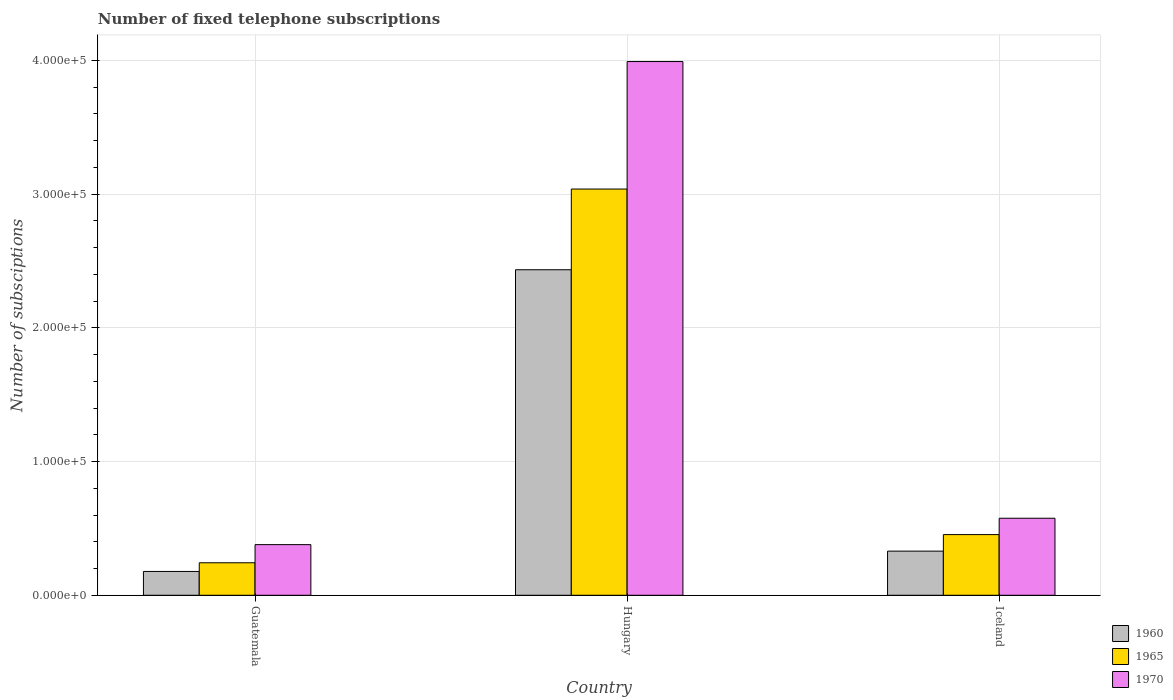How many different coloured bars are there?
Provide a short and direct response. 3. How many groups of bars are there?
Make the answer very short. 3. How many bars are there on the 1st tick from the right?
Give a very brief answer. 3. What is the label of the 2nd group of bars from the left?
Provide a short and direct response. Hungary. What is the number of fixed telephone subscriptions in 1960 in Iceland?
Give a very brief answer. 3.30e+04. Across all countries, what is the maximum number of fixed telephone subscriptions in 1970?
Ensure brevity in your answer.  3.99e+05. Across all countries, what is the minimum number of fixed telephone subscriptions in 1970?
Provide a succinct answer. 3.79e+04. In which country was the number of fixed telephone subscriptions in 1970 maximum?
Give a very brief answer. Hungary. In which country was the number of fixed telephone subscriptions in 1970 minimum?
Make the answer very short. Guatemala. What is the total number of fixed telephone subscriptions in 1960 in the graph?
Make the answer very short. 2.94e+05. What is the difference between the number of fixed telephone subscriptions in 1960 in Hungary and that in Iceland?
Give a very brief answer. 2.10e+05. What is the difference between the number of fixed telephone subscriptions in 1965 in Guatemala and the number of fixed telephone subscriptions in 1960 in Hungary?
Keep it short and to the point. -2.19e+05. What is the average number of fixed telephone subscriptions in 1970 per country?
Your answer should be compact. 1.65e+05. What is the difference between the number of fixed telephone subscriptions of/in 1965 and number of fixed telephone subscriptions of/in 1960 in Hungary?
Ensure brevity in your answer.  6.04e+04. What is the ratio of the number of fixed telephone subscriptions in 1960 in Guatemala to that in Iceland?
Make the answer very short. 0.54. Is the number of fixed telephone subscriptions in 1960 in Guatemala less than that in Hungary?
Your response must be concise. Yes. What is the difference between the highest and the second highest number of fixed telephone subscriptions in 1970?
Offer a very short reply. 3.41e+05. What is the difference between the highest and the lowest number of fixed telephone subscriptions in 1965?
Make the answer very short. 2.79e+05. What does the 1st bar from the left in Hungary represents?
Offer a very short reply. 1960. What does the 2nd bar from the right in Iceland represents?
Offer a very short reply. 1965. How many bars are there?
Keep it short and to the point. 9. Are all the bars in the graph horizontal?
Your response must be concise. No. What is the difference between two consecutive major ticks on the Y-axis?
Offer a terse response. 1.00e+05. Are the values on the major ticks of Y-axis written in scientific E-notation?
Make the answer very short. Yes. Where does the legend appear in the graph?
Keep it short and to the point. Bottom right. How are the legend labels stacked?
Offer a terse response. Vertical. What is the title of the graph?
Offer a terse response. Number of fixed telephone subscriptions. Does "2006" appear as one of the legend labels in the graph?
Make the answer very short. No. What is the label or title of the X-axis?
Provide a succinct answer. Country. What is the label or title of the Y-axis?
Offer a terse response. Number of subsciptions. What is the Number of subsciptions in 1960 in Guatemala?
Offer a terse response. 1.78e+04. What is the Number of subsciptions in 1965 in Guatemala?
Your answer should be very brief. 2.43e+04. What is the Number of subsciptions in 1970 in Guatemala?
Keep it short and to the point. 3.79e+04. What is the Number of subsciptions in 1960 in Hungary?
Your answer should be compact. 2.43e+05. What is the Number of subsciptions of 1965 in Hungary?
Your response must be concise. 3.04e+05. What is the Number of subsciptions of 1970 in Hungary?
Your answer should be very brief. 3.99e+05. What is the Number of subsciptions in 1960 in Iceland?
Give a very brief answer. 3.30e+04. What is the Number of subsciptions in 1965 in Iceland?
Ensure brevity in your answer.  4.54e+04. What is the Number of subsciptions of 1970 in Iceland?
Provide a short and direct response. 5.76e+04. Across all countries, what is the maximum Number of subsciptions in 1960?
Offer a very short reply. 2.43e+05. Across all countries, what is the maximum Number of subsciptions in 1965?
Offer a terse response. 3.04e+05. Across all countries, what is the maximum Number of subsciptions in 1970?
Offer a very short reply. 3.99e+05. Across all countries, what is the minimum Number of subsciptions in 1960?
Offer a terse response. 1.78e+04. Across all countries, what is the minimum Number of subsciptions of 1965?
Give a very brief answer. 2.43e+04. Across all countries, what is the minimum Number of subsciptions in 1970?
Offer a very short reply. 3.79e+04. What is the total Number of subsciptions in 1960 in the graph?
Give a very brief answer. 2.94e+05. What is the total Number of subsciptions in 1965 in the graph?
Your answer should be compact. 3.73e+05. What is the total Number of subsciptions of 1970 in the graph?
Your response must be concise. 4.95e+05. What is the difference between the Number of subsciptions in 1960 in Guatemala and that in Hungary?
Your response must be concise. -2.26e+05. What is the difference between the Number of subsciptions in 1965 in Guatemala and that in Hungary?
Give a very brief answer. -2.79e+05. What is the difference between the Number of subsciptions in 1970 in Guatemala and that in Hungary?
Offer a very short reply. -3.61e+05. What is the difference between the Number of subsciptions in 1960 in Guatemala and that in Iceland?
Your answer should be very brief. -1.52e+04. What is the difference between the Number of subsciptions of 1965 in Guatemala and that in Iceland?
Offer a very short reply. -2.11e+04. What is the difference between the Number of subsciptions of 1970 in Guatemala and that in Iceland?
Offer a very short reply. -1.97e+04. What is the difference between the Number of subsciptions in 1960 in Hungary and that in Iceland?
Provide a succinct answer. 2.10e+05. What is the difference between the Number of subsciptions in 1965 in Hungary and that in Iceland?
Your answer should be compact. 2.58e+05. What is the difference between the Number of subsciptions in 1970 in Hungary and that in Iceland?
Make the answer very short. 3.41e+05. What is the difference between the Number of subsciptions in 1960 in Guatemala and the Number of subsciptions in 1965 in Hungary?
Give a very brief answer. -2.86e+05. What is the difference between the Number of subsciptions in 1960 in Guatemala and the Number of subsciptions in 1970 in Hungary?
Ensure brevity in your answer.  -3.81e+05. What is the difference between the Number of subsciptions in 1965 in Guatemala and the Number of subsciptions in 1970 in Hungary?
Your answer should be compact. -3.75e+05. What is the difference between the Number of subsciptions of 1960 in Guatemala and the Number of subsciptions of 1965 in Iceland?
Your answer should be very brief. -2.75e+04. What is the difference between the Number of subsciptions of 1960 in Guatemala and the Number of subsciptions of 1970 in Iceland?
Your answer should be very brief. -3.98e+04. What is the difference between the Number of subsciptions in 1965 in Guatemala and the Number of subsciptions in 1970 in Iceland?
Offer a very short reply. -3.33e+04. What is the difference between the Number of subsciptions of 1960 in Hungary and the Number of subsciptions of 1965 in Iceland?
Keep it short and to the point. 1.98e+05. What is the difference between the Number of subsciptions in 1960 in Hungary and the Number of subsciptions in 1970 in Iceland?
Provide a short and direct response. 1.86e+05. What is the difference between the Number of subsciptions in 1965 in Hungary and the Number of subsciptions in 1970 in Iceland?
Your answer should be very brief. 2.46e+05. What is the average Number of subsciptions of 1960 per country?
Your response must be concise. 9.81e+04. What is the average Number of subsciptions in 1965 per country?
Ensure brevity in your answer.  1.24e+05. What is the average Number of subsciptions in 1970 per country?
Ensure brevity in your answer.  1.65e+05. What is the difference between the Number of subsciptions of 1960 and Number of subsciptions of 1965 in Guatemala?
Keep it short and to the point. -6485. What is the difference between the Number of subsciptions of 1960 and Number of subsciptions of 1970 in Guatemala?
Make the answer very short. -2.00e+04. What is the difference between the Number of subsciptions of 1965 and Number of subsciptions of 1970 in Guatemala?
Offer a very short reply. -1.36e+04. What is the difference between the Number of subsciptions of 1960 and Number of subsciptions of 1965 in Hungary?
Offer a terse response. -6.04e+04. What is the difference between the Number of subsciptions of 1960 and Number of subsciptions of 1970 in Hungary?
Offer a terse response. -1.56e+05. What is the difference between the Number of subsciptions of 1965 and Number of subsciptions of 1970 in Hungary?
Make the answer very short. -9.53e+04. What is the difference between the Number of subsciptions of 1960 and Number of subsciptions of 1965 in Iceland?
Offer a terse response. -1.24e+04. What is the difference between the Number of subsciptions in 1960 and Number of subsciptions in 1970 in Iceland?
Your answer should be compact. -2.46e+04. What is the difference between the Number of subsciptions of 1965 and Number of subsciptions of 1970 in Iceland?
Offer a very short reply. -1.22e+04. What is the ratio of the Number of subsciptions of 1960 in Guatemala to that in Hungary?
Provide a succinct answer. 0.07. What is the ratio of the Number of subsciptions of 1970 in Guatemala to that in Hungary?
Your answer should be compact. 0.09. What is the ratio of the Number of subsciptions in 1960 in Guatemala to that in Iceland?
Provide a short and direct response. 0.54. What is the ratio of the Number of subsciptions in 1965 in Guatemala to that in Iceland?
Keep it short and to the point. 0.54. What is the ratio of the Number of subsciptions of 1970 in Guatemala to that in Iceland?
Make the answer very short. 0.66. What is the ratio of the Number of subsciptions in 1960 in Hungary to that in Iceland?
Ensure brevity in your answer.  7.38. What is the ratio of the Number of subsciptions of 1965 in Hungary to that in Iceland?
Your response must be concise. 6.7. What is the ratio of the Number of subsciptions of 1970 in Hungary to that in Iceland?
Your response must be concise. 6.93. What is the difference between the highest and the second highest Number of subsciptions of 1960?
Ensure brevity in your answer.  2.10e+05. What is the difference between the highest and the second highest Number of subsciptions in 1965?
Offer a terse response. 2.58e+05. What is the difference between the highest and the second highest Number of subsciptions in 1970?
Ensure brevity in your answer.  3.41e+05. What is the difference between the highest and the lowest Number of subsciptions in 1960?
Your answer should be very brief. 2.26e+05. What is the difference between the highest and the lowest Number of subsciptions of 1965?
Your answer should be very brief. 2.79e+05. What is the difference between the highest and the lowest Number of subsciptions in 1970?
Your answer should be very brief. 3.61e+05. 